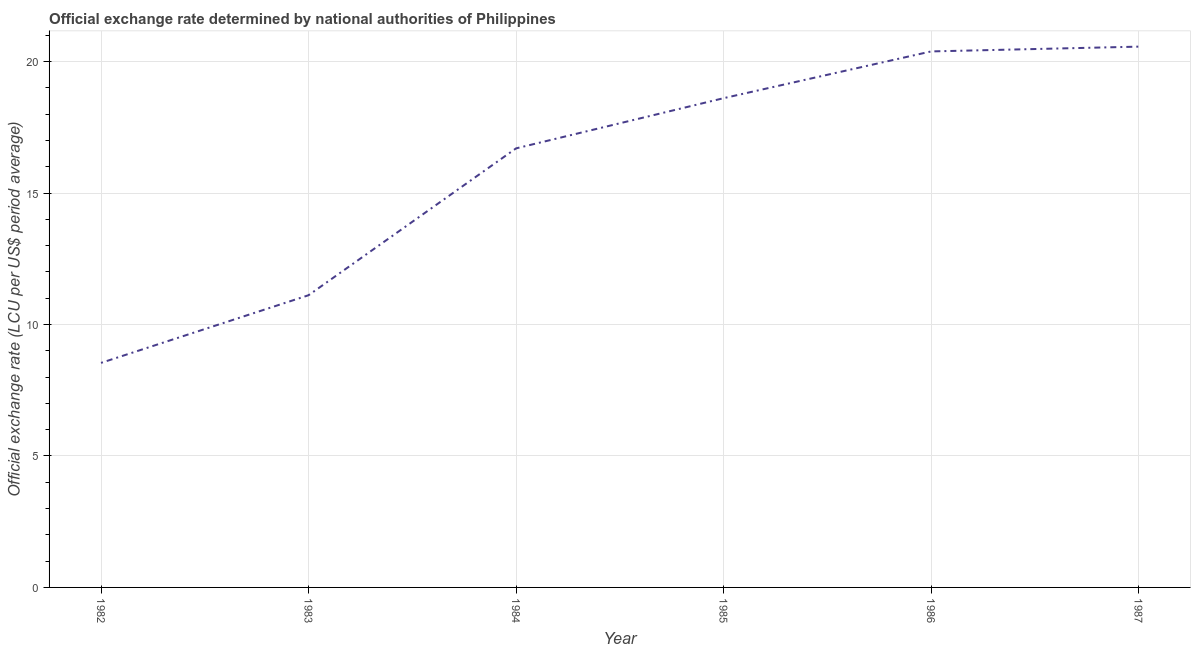What is the official exchange rate in 1984?
Ensure brevity in your answer.  16.7. Across all years, what is the maximum official exchange rate?
Give a very brief answer. 20.57. Across all years, what is the minimum official exchange rate?
Offer a terse response. 8.54. In which year was the official exchange rate minimum?
Your response must be concise. 1982. What is the sum of the official exchange rate?
Provide a short and direct response. 95.91. What is the difference between the official exchange rate in 1986 and 1987?
Offer a very short reply. -0.18. What is the average official exchange rate per year?
Your response must be concise. 15.99. What is the median official exchange rate?
Your answer should be compact. 17.65. Do a majority of the years between 1986 and 1985 (inclusive) have official exchange rate greater than 19 ?
Provide a succinct answer. No. What is the ratio of the official exchange rate in 1982 to that in 1986?
Offer a terse response. 0.42. Is the official exchange rate in 1985 less than that in 1987?
Give a very brief answer. Yes. Is the difference between the official exchange rate in 1984 and 1987 greater than the difference between any two years?
Your answer should be very brief. No. What is the difference between the highest and the second highest official exchange rate?
Ensure brevity in your answer.  0.18. What is the difference between the highest and the lowest official exchange rate?
Offer a terse response. 12.03. In how many years, is the official exchange rate greater than the average official exchange rate taken over all years?
Offer a very short reply. 4. How many lines are there?
Your answer should be very brief. 1. How many years are there in the graph?
Offer a terse response. 6. Does the graph contain any zero values?
Your answer should be compact. No. What is the title of the graph?
Give a very brief answer. Official exchange rate determined by national authorities of Philippines. What is the label or title of the X-axis?
Ensure brevity in your answer.  Year. What is the label or title of the Y-axis?
Give a very brief answer. Official exchange rate (LCU per US$ period average). What is the Official exchange rate (LCU per US$ period average) of 1982?
Offer a terse response. 8.54. What is the Official exchange rate (LCU per US$ period average) in 1983?
Provide a succinct answer. 11.11. What is the Official exchange rate (LCU per US$ period average) of 1984?
Offer a terse response. 16.7. What is the Official exchange rate (LCU per US$ period average) of 1985?
Offer a terse response. 18.61. What is the Official exchange rate (LCU per US$ period average) of 1986?
Give a very brief answer. 20.39. What is the Official exchange rate (LCU per US$ period average) of 1987?
Keep it short and to the point. 20.57. What is the difference between the Official exchange rate (LCU per US$ period average) in 1982 and 1983?
Your answer should be very brief. -2.57. What is the difference between the Official exchange rate (LCU per US$ period average) in 1982 and 1984?
Your response must be concise. -8.16. What is the difference between the Official exchange rate (LCU per US$ period average) in 1982 and 1985?
Keep it short and to the point. -10.07. What is the difference between the Official exchange rate (LCU per US$ period average) in 1982 and 1986?
Your answer should be compact. -11.85. What is the difference between the Official exchange rate (LCU per US$ period average) in 1982 and 1987?
Give a very brief answer. -12.03. What is the difference between the Official exchange rate (LCU per US$ period average) in 1983 and 1984?
Offer a very short reply. -5.59. What is the difference between the Official exchange rate (LCU per US$ period average) in 1983 and 1985?
Offer a terse response. -7.49. What is the difference between the Official exchange rate (LCU per US$ period average) in 1983 and 1986?
Make the answer very short. -9.27. What is the difference between the Official exchange rate (LCU per US$ period average) in 1983 and 1987?
Give a very brief answer. -9.45. What is the difference between the Official exchange rate (LCU per US$ period average) in 1984 and 1985?
Your response must be concise. -1.91. What is the difference between the Official exchange rate (LCU per US$ period average) in 1984 and 1986?
Your answer should be compact. -3.69. What is the difference between the Official exchange rate (LCU per US$ period average) in 1984 and 1987?
Provide a succinct answer. -3.87. What is the difference between the Official exchange rate (LCU per US$ period average) in 1985 and 1986?
Provide a succinct answer. -1.78. What is the difference between the Official exchange rate (LCU per US$ period average) in 1985 and 1987?
Provide a succinct answer. -1.96. What is the difference between the Official exchange rate (LCU per US$ period average) in 1986 and 1987?
Offer a terse response. -0.18. What is the ratio of the Official exchange rate (LCU per US$ period average) in 1982 to that in 1983?
Offer a very short reply. 0.77. What is the ratio of the Official exchange rate (LCU per US$ period average) in 1982 to that in 1984?
Offer a terse response. 0.51. What is the ratio of the Official exchange rate (LCU per US$ period average) in 1982 to that in 1985?
Offer a terse response. 0.46. What is the ratio of the Official exchange rate (LCU per US$ period average) in 1982 to that in 1986?
Your answer should be very brief. 0.42. What is the ratio of the Official exchange rate (LCU per US$ period average) in 1982 to that in 1987?
Give a very brief answer. 0.41. What is the ratio of the Official exchange rate (LCU per US$ period average) in 1983 to that in 1984?
Ensure brevity in your answer.  0.67. What is the ratio of the Official exchange rate (LCU per US$ period average) in 1983 to that in 1985?
Provide a succinct answer. 0.6. What is the ratio of the Official exchange rate (LCU per US$ period average) in 1983 to that in 1986?
Ensure brevity in your answer.  0.55. What is the ratio of the Official exchange rate (LCU per US$ period average) in 1983 to that in 1987?
Offer a very short reply. 0.54. What is the ratio of the Official exchange rate (LCU per US$ period average) in 1984 to that in 1985?
Your answer should be compact. 0.9. What is the ratio of the Official exchange rate (LCU per US$ period average) in 1984 to that in 1986?
Your answer should be very brief. 0.82. What is the ratio of the Official exchange rate (LCU per US$ period average) in 1984 to that in 1987?
Your response must be concise. 0.81. What is the ratio of the Official exchange rate (LCU per US$ period average) in 1985 to that in 1987?
Give a very brief answer. 0.91. What is the ratio of the Official exchange rate (LCU per US$ period average) in 1986 to that in 1987?
Provide a short and direct response. 0.99. 